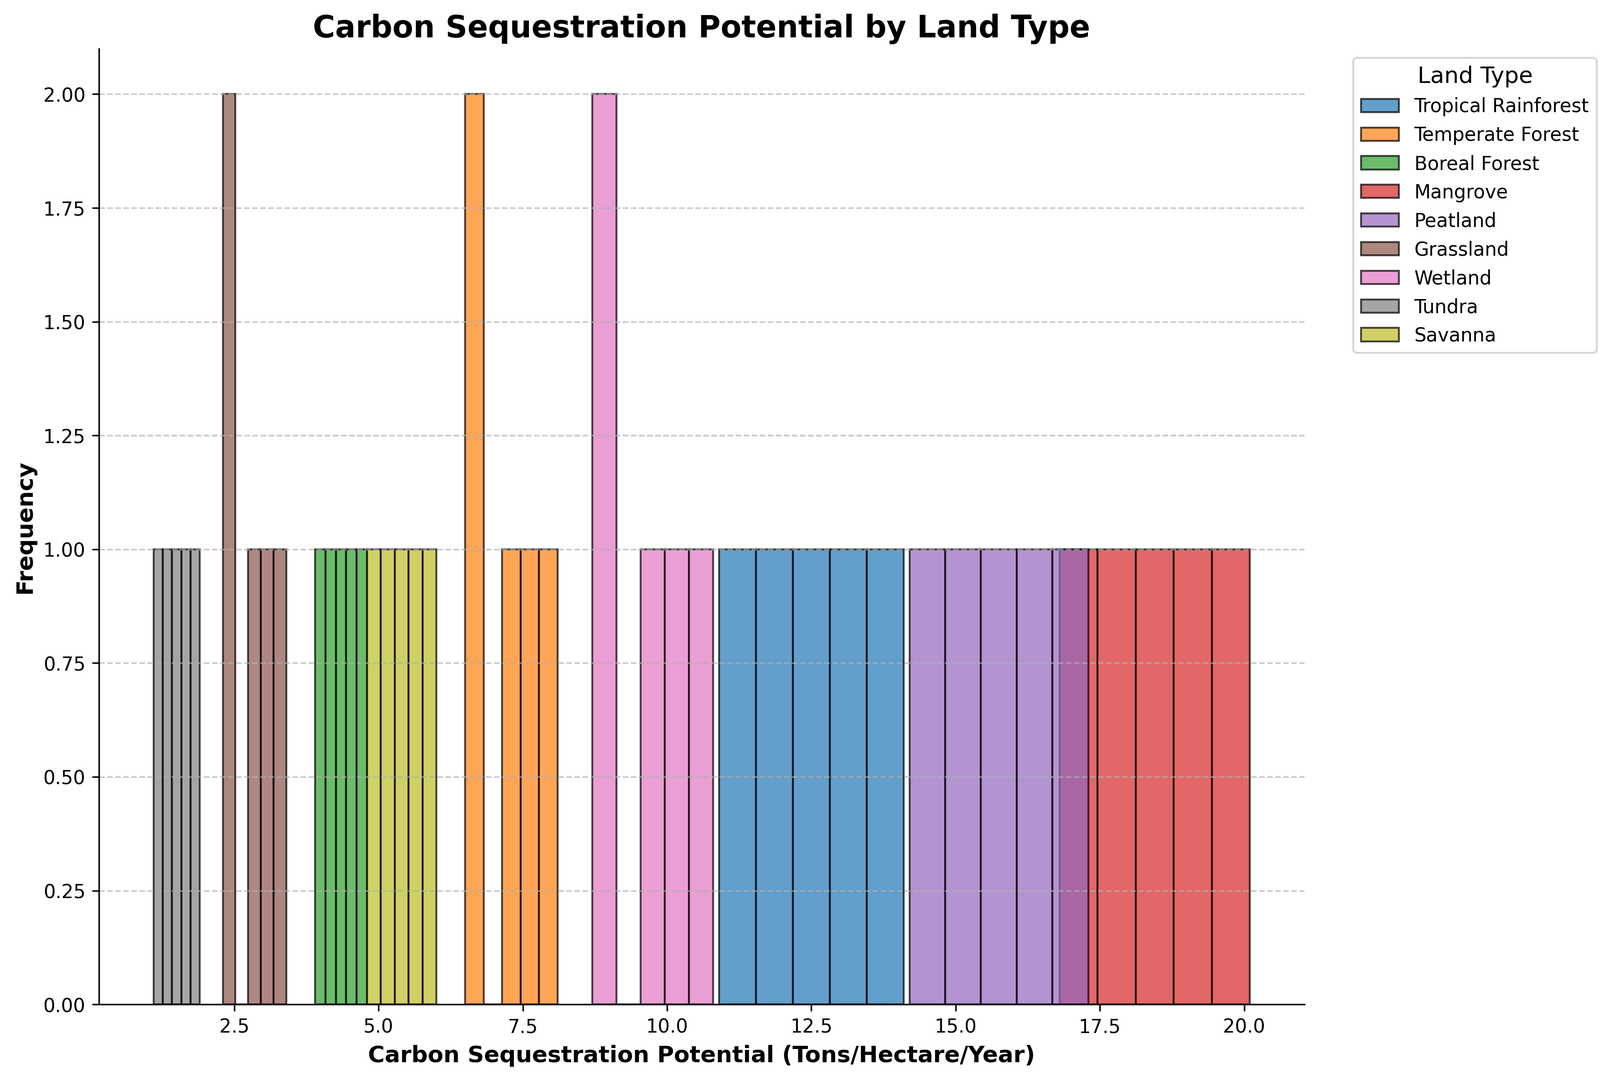Which land type has the highest carbon sequestration potential? By identifying the histogram bar that extends furthest to the right, we can see which land type has the highest carbon sequestration potential.
Answer: Mangrove Which land type has the lowest carbon sequestration potential? By identifying the histogram bar that extends furthest to the left, we can see which land type has the lowest carbon sequestration potential.
Answer: Tundra What is the average carbon sequestration potential for Tropical Rainforest and Temperate Forest combined? First, find the average for Tropical Rainforest: (12.5 + 11.8 + 13.2 + 10.9 + 14.1) / 5 = 12.5. Next, find the average for Temperate Forest: (7.2 + 6.8 + 7.5 + 6.5 + 8.1) / 5 = 7.22. Finally, average these two values: (12.5 + 7.22) / 2 = 9.85.
Answer: 9.85 How does the carbon sequestration potential of Wetlands compare to that of Grasslands? Observing the histogram bars for Wetlands and Grasslands shows that all Wetlands values are higher than all Grasslands values.
Answer: Wetlands are higher than Grasslands Which type of land has the most consistent carbon sequestration potential? Consistency can be interpreted by the narrowest spread in the histogram bars; the least variance. The histograms with bunched frequencies indicate lower variance.
Answer: Boreal Forest In Tropical Rainforest, what is the range of carbon sequestration potential? The range can be found by subtracting the smallest value from the largest value within the Tropical Rainforest bar values: 14.1 - 10.9 = 3.2.
Answer: 3.2 Which land type shows the greatest variability in carbon sequestration potential? The greatest variability is indicated by the widest spread in the histogram bars. By comparing the range of each, we identify the widest spread.
Answer: Mangrove Between Savanna and Grassland, which has a larger average carbon sequestration potential? Calculate the average for Savanna: (5.4 + 5.1 + 5.7 + 4.8 + 6.0) / 5 = 5.4. Calculate the average for Grassland: (2.8 + 2.5 + 3.1 + 2.3 + 3.4) / 5 = 2.82. Compare these averages.
Answer: Savanna What is the median carbon sequestration potential for Mangroves? First, arrange the values for Mangrove: [16.8, 17.9, 18.5, 19.2, 20.1]. The median is the middle value: 18.5.
Answer: 18.5 Which land type has the highest frequency within its highest bin? Reviewing the histogram, identify the land type with the tallest bar within its highest frequency bin.
Answer: Mangrove 